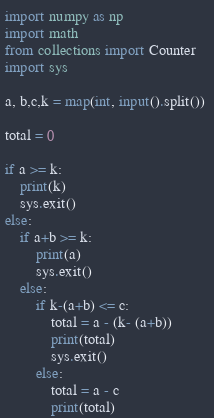<code> <loc_0><loc_0><loc_500><loc_500><_Python_>
import numpy as np
import math
from collections import Counter
import sys

a, b,c,k = map(int, input().split()) 

total = 0

if a >= k:
    print(k)
    sys.exit()
else:
    if a+b >= k:
        print(a)
        sys.exit()
    else:
        if k-(a+b) <= c:
            total = a - (k- (a+b))
            print(total)
            sys.exit()
        else:
            total = a - c
            print(total)</code> 